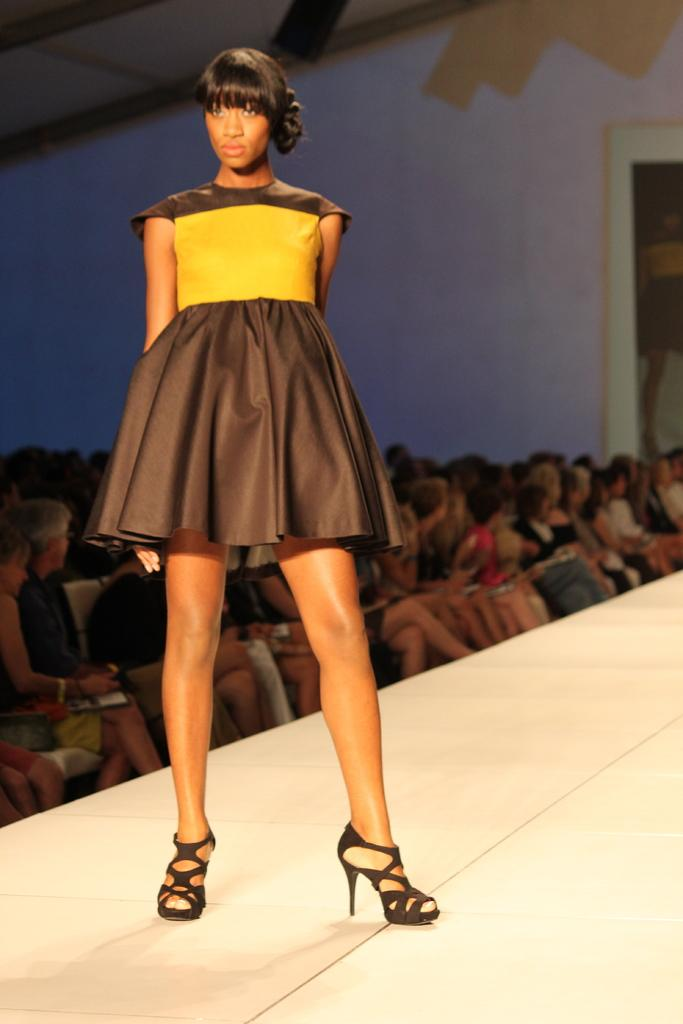What is the girl in the image doing? The girl is standing on a ramp in the image. What can be seen in the background of the image? There are many people sitting in the background of the image, and there is also a wall visible. Can you see any monkeys or boats in the image? No, there are no monkeys or boats present in the image. 